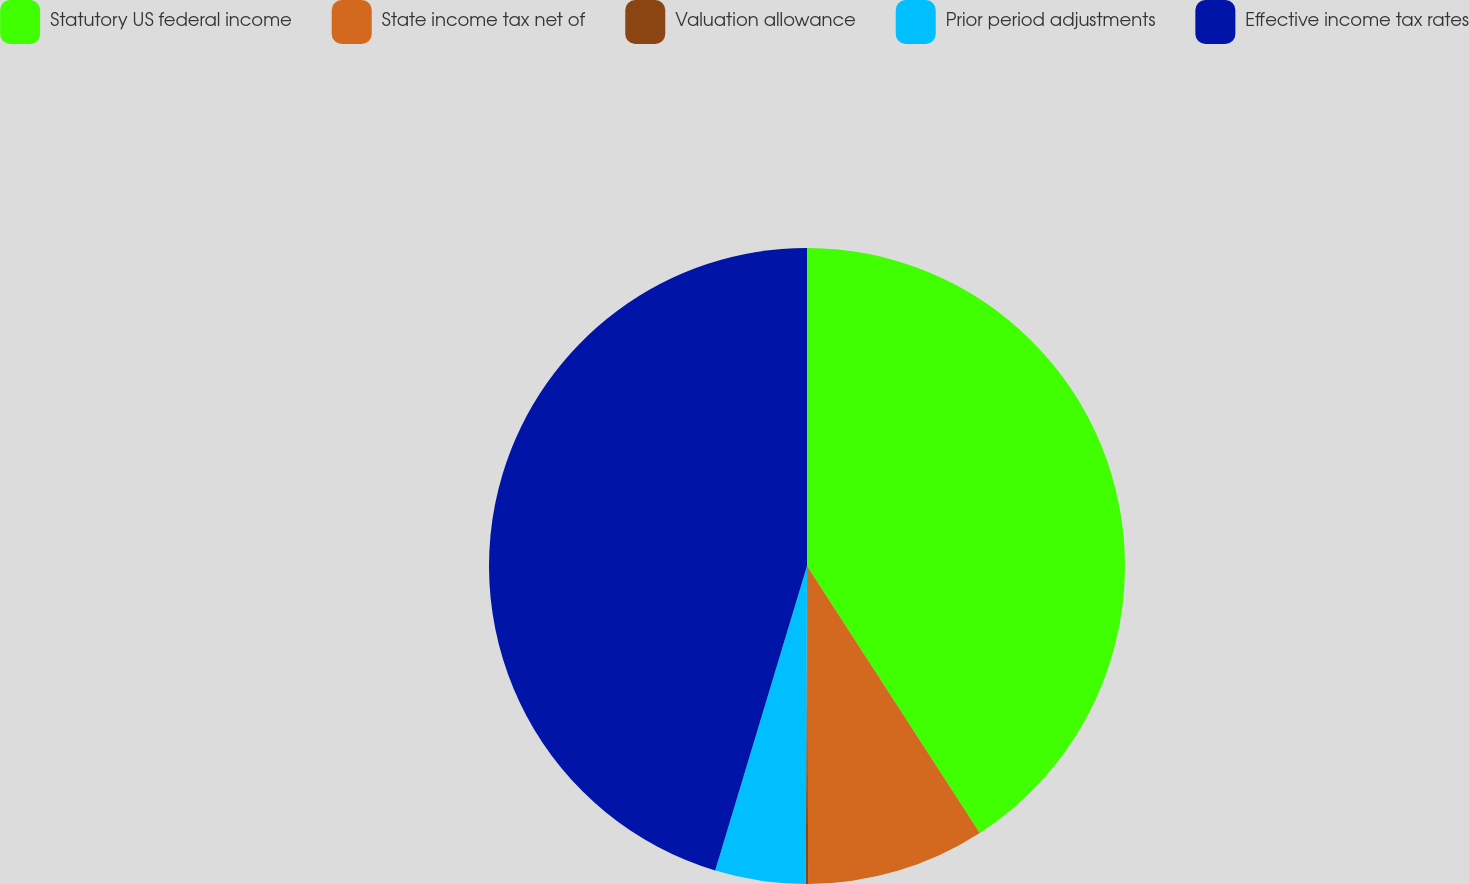Convert chart to OTSL. <chart><loc_0><loc_0><loc_500><loc_500><pie_chart><fcel>Statutory US federal income<fcel>State income tax net of<fcel>Valuation allowance<fcel>Prior period adjustments<fcel>Effective income tax rates<nl><fcel>40.86%<fcel>9.08%<fcel>0.12%<fcel>4.6%<fcel>45.34%<nl></chart> 